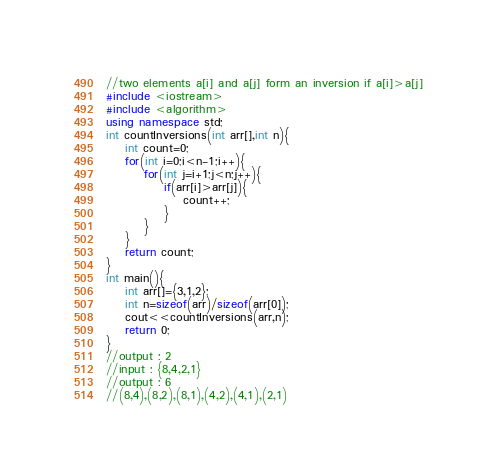<code> <loc_0><loc_0><loc_500><loc_500><_C++_>//two elements a[i] and a[j] form an inversion if a[i]>a[j]
#include <iostream>
#include <algorithm>
using namespace std;
int countInversions(int arr[],int n){
    int count=0;
    for(int i=0;i<n-1;i++){
        for(int j=i+1;j<n;j++){
            if(arr[i]>arr[j]){
                count++;
            }
        }
    }
    return count;
}
int main(){
    int arr[]={3,1,2};
    int n=sizeof(arr)/sizeof(arr[0]);
    cout<<countInversions(arr,n);
    return 0;
}
//output : 2 
//input : {8,4,2,1}
//output : 6 
//(8,4),(8,2),(8,1),(4,2),(4,1),(2,1)
</code> 